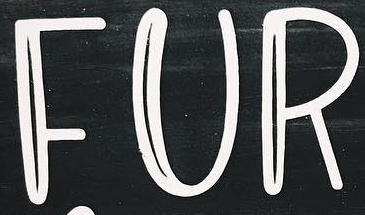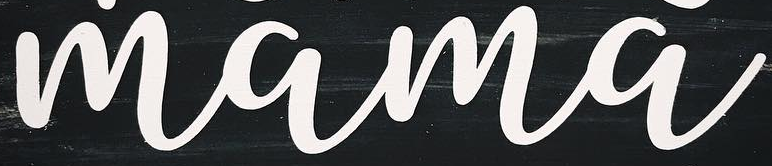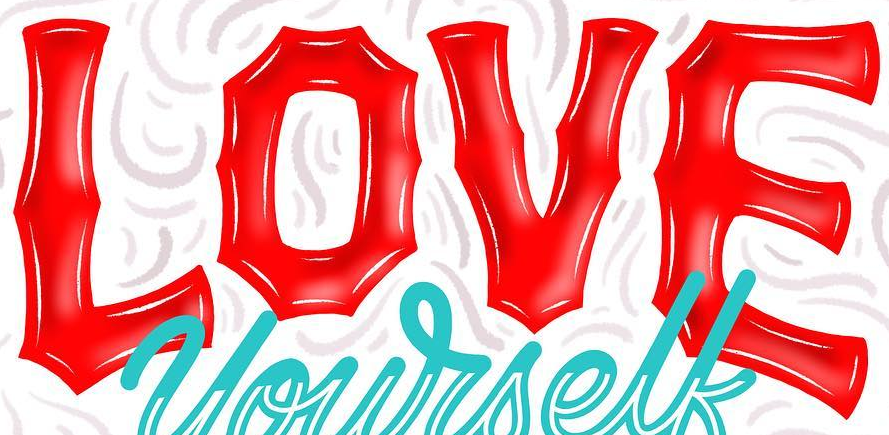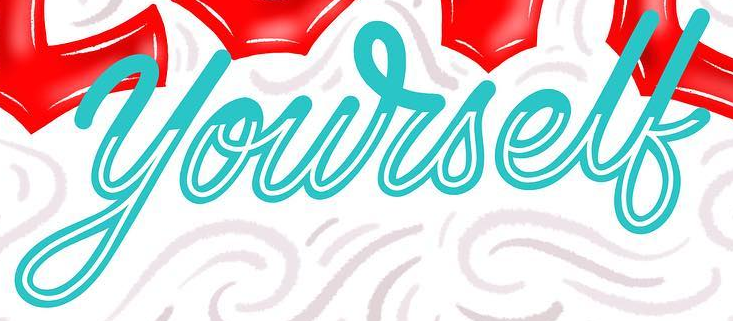What words can you see in these images in sequence, separated by a semicolon? FUR; mama; LOVE; yourself 